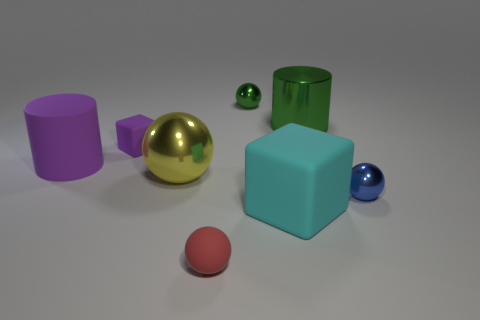Are there fewer metallic objects in front of the yellow metal sphere than big objects left of the big block?
Your response must be concise. Yes. There is a matte thing that is to the right of the red object; what is its shape?
Ensure brevity in your answer.  Cube. Does the large yellow object have the same material as the red thing?
Provide a succinct answer. No. What material is the tiny blue thing that is the same shape as the tiny red thing?
Give a very brief answer. Metal. Is the number of yellow objects to the right of the big green metallic thing less than the number of large cyan things?
Ensure brevity in your answer.  Yes. There is a large ball; what number of tiny rubber things are behind it?
Your response must be concise. 1. Is the shape of the large metallic thing behind the large yellow shiny object the same as the large matte thing behind the big cyan rubber block?
Your response must be concise. Yes. What shape is the big thing that is both to the right of the red rubber sphere and in front of the tiny matte block?
Give a very brief answer. Cube. The red object that is made of the same material as the large cube is what size?
Ensure brevity in your answer.  Small. Is the number of tiny green things less than the number of gray spheres?
Make the answer very short. No. 